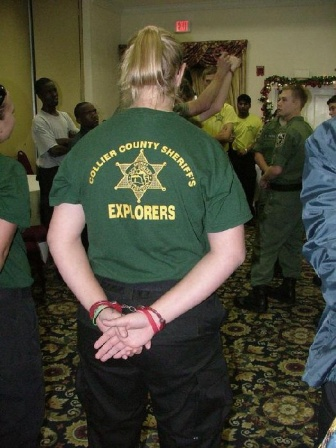What's happening in this image? Can you describe it in a friendly way? Sure! This image shows a lively gathering of the Collier County Sheriff's Explorers, a group likely consisting of young individuals involved in community or law enforcement activities. They're all dressed in matching green t-shirts, which makes it feel very much like a team event. It looks like they’re celebrating something special—perhaps Christmas—given the festive decorations on the walls. Everyone seems to be engaged and enjoying the occasion, contributing to a warm and friendly atmosphere. 